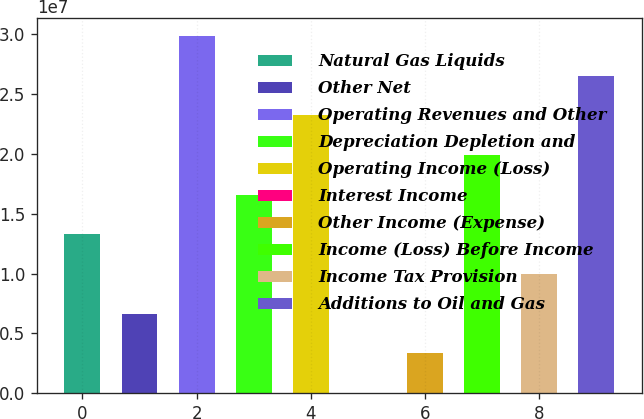Convert chart. <chart><loc_0><loc_0><loc_500><loc_500><bar_chart><fcel>Natural Gas Liquids<fcel>Other Net<fcel>Operating Revenues and Other<fcel>Depreciation Depletion and<fcel>Operating Income (Loss)<fcel>Interest Income<fcel>Other Income (Expense)<fcel>Income (Loss) Before Income<fcel>Income Tax Provision<fcel>Additions to Oil and Gas<nl><fcel>1.32771e+07<fcel>6.64321e+06<fcel>2.98618e+07<fcel>1.6594e+07<fcel>2.32279e+07<fcel>9326<fcel>3.32627e+06<fcel>1.9911e+07<fcel>9.96015e+06<fcel>2.65449e+07<nl></chart> 